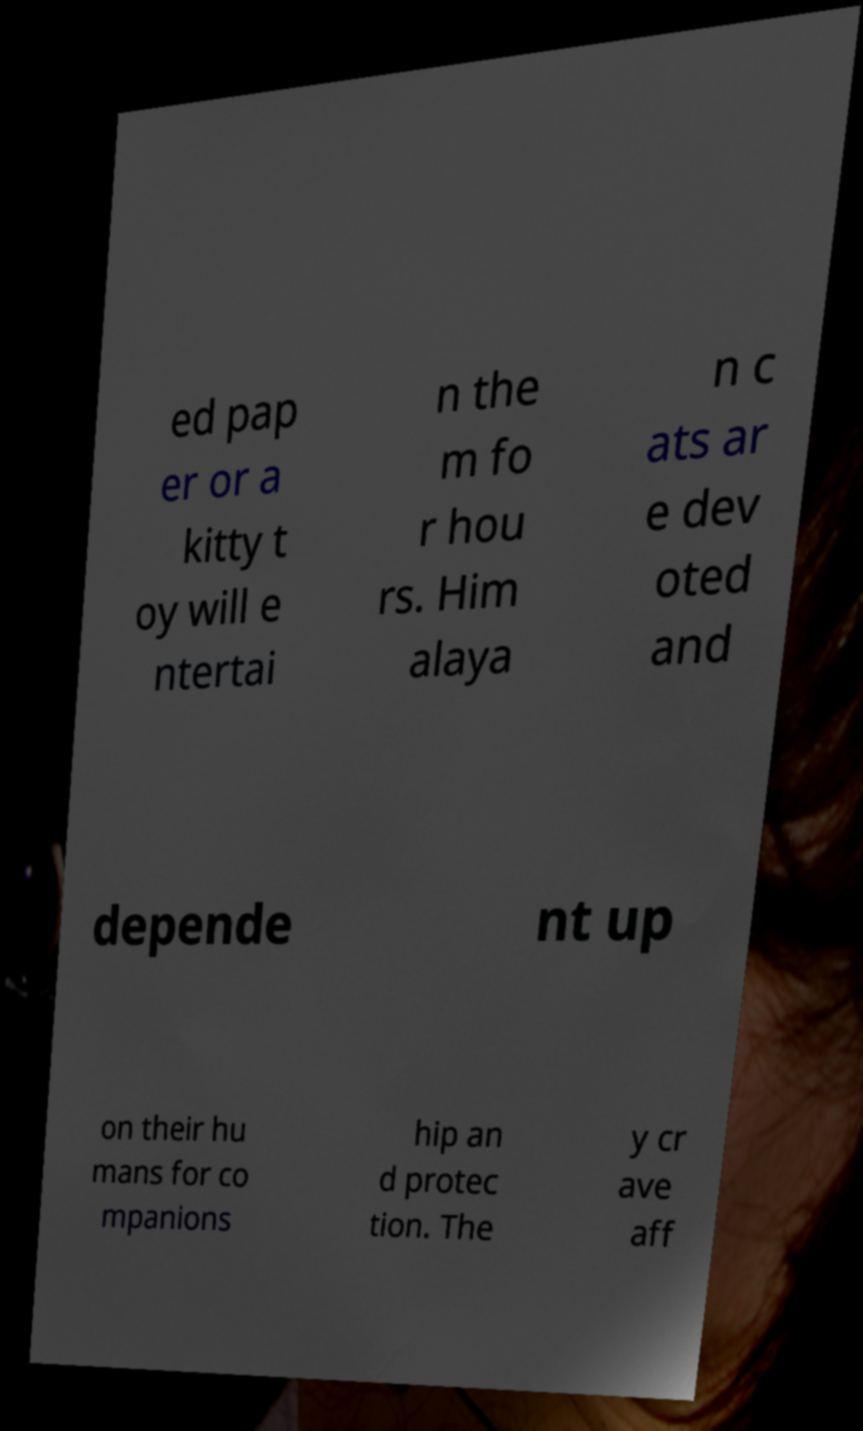What messages or text are displayed in this image? I need them in a readable, typed format. ed pap er or a kitty t oy will e ntertai n the m fo r hou rs. Him alaya n c ats ar e dev oted and depende nt up on their hu mans for co mpanions hip an d protec tion. The y cr ave aff 